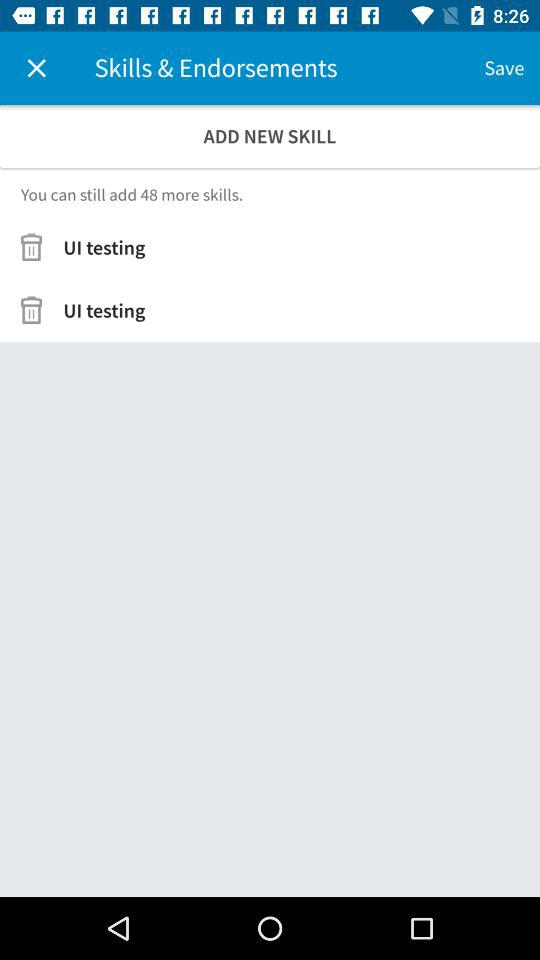How many skills can be added?
Answer the question using a single word or phrase. 48 